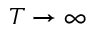Convert formula to latex. <formula><loc_0><loc_0><loc_500><loc_500>T \to \infty</formula> 